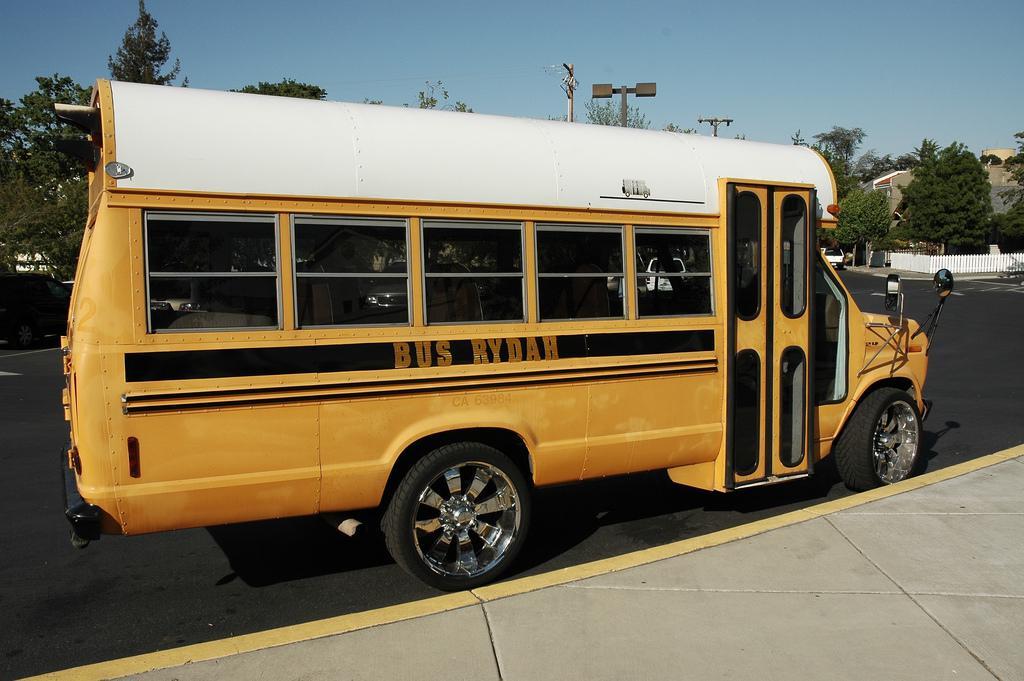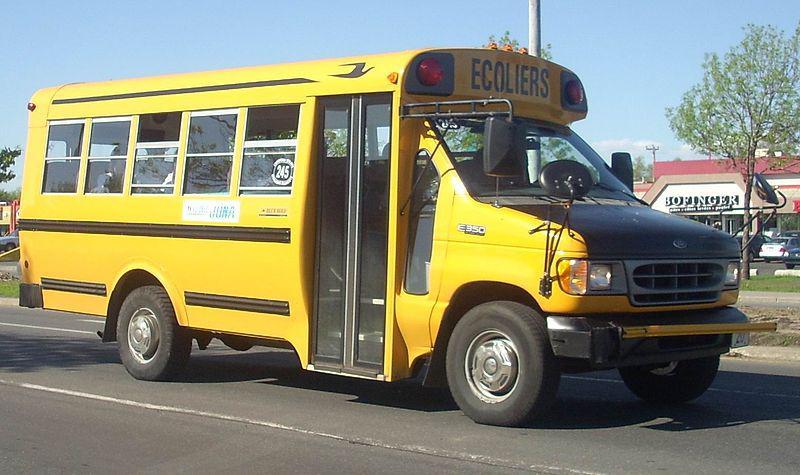The first image is the image on the left, the second image is the image on the right. Assess this claim about the two images: "The combined images show two buses heading in the same direction with a shorter bus appearing to be leading.". Correct or not? Answer yes or no. No. 